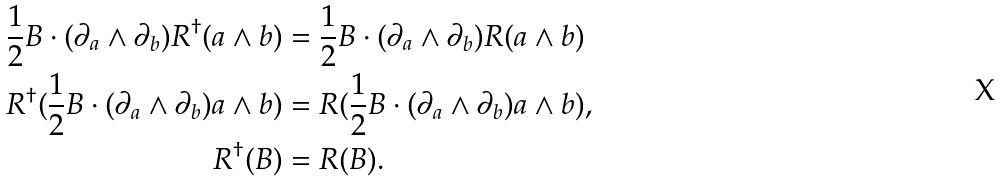Convert formula to latex. <formula><loc_0><loc_0><loc_500><loc_500>\frac { 1 } { 2 } B \cdot ( \partial _ { a } \wedge \partial _ { b } ) R ^ { \dagger } ( a \wedge b ) & = \frac { 1 } { 2 } B \cdot ( \partial _ { a } \wedge \partial _ { b } ) R ( a \wedge b ) \\ R ^ { \dagger } ( \frac { 1 } { 2 } B \cdot ( \partial _ { a } \wedge \partial _ { b } ) a \wedge b ) & = R ( \frac { 1 } { 2 } B \cdot ( \partial _ { a } \wedge \partial _ { b } ) a \wedge b ) , \\ R ^ { \dagger } ( B ) & = R ( B ) .</formula> 